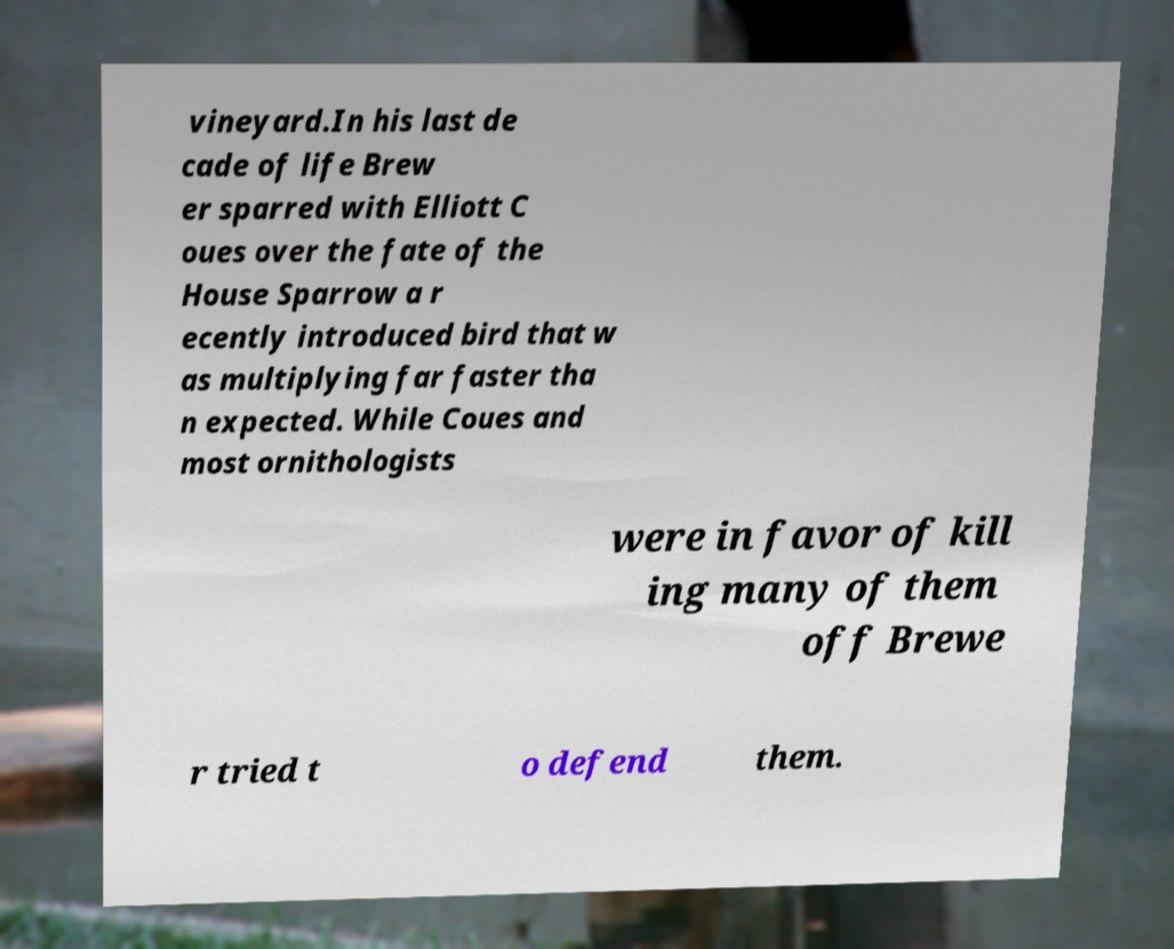For documentation purposes, I need the text within this image transcribed. Could you provide that? vineyard.In his last de cade of life Brew er sparred with Elliott C oues over the fate of the House Sparrow a r ecently introduced bird that w as multiplying far faster tha n expected. While Coues and most ornithologists were in favor of kill ing many of them off Brewe r tried t o defend them. 